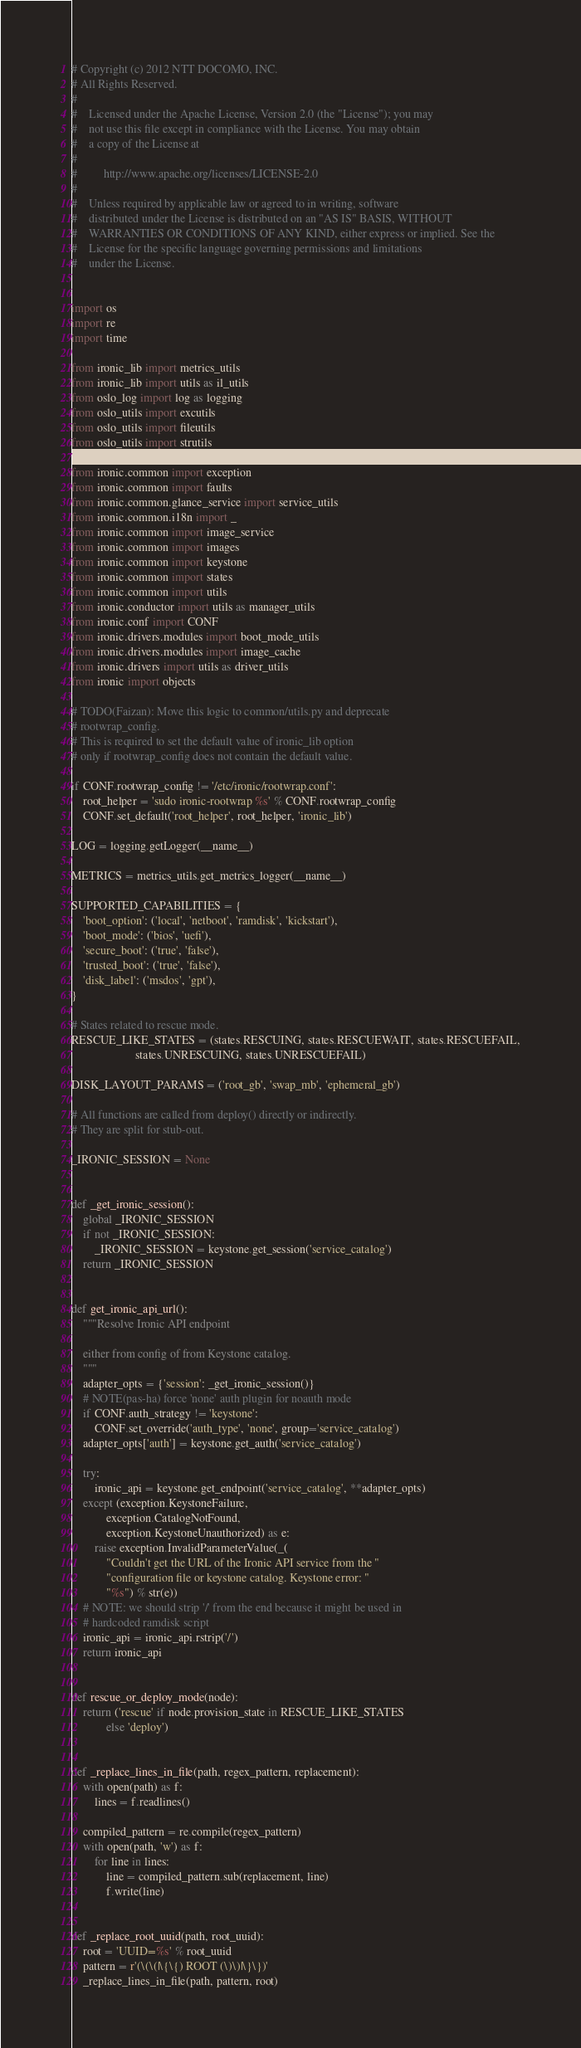Convert code to text. <code><loc_0><loc_0><loc_500><loc_500><_Python_># Copyright (c) 2012 NTT DOCOMO, INC.
# All Rights Reserved.
#
#    Licensed under the Apache License, Version 2.0 (the "License"); you may
#    not use this file except in compliance with the License. You may obtain
#    a copy of the License at
#
#         http://www.apache.org/licenses/LICENSE-2.0
#
#    Unless required by applicable law or agreed to in writing, software
#    distributed under the License is distributed on an "AS IS" BASIS, WITHOUT
#    WARRANTIES OR CONDITIONS OF ANY KIND, either express or implied. See the
#    License for the specific language governing permissions and limitations
#    under the License.


import os
import re
import time

from ironic_lib import metrics_utils
from ironic_lib import utils as il_utils
from oslo_log import log as logging
from oslo_utils import excutils
from oslo_utils import fileutils
from oslo_utils import strutils

from ironic.common import exception
from ironic.common import faults
from ironic.common.glance_service import service_utils
from ironic.common.i18n import _
from ironic.common import image_service
from ironic.common import images
from ironic.common import keystone
from ironic.common import states
from ironic.common import utils
from ironic.conductor import utils as manager_utils
from ironic.conf import CONF
from ironic.drivers.modules import boot_mode_utils
from ironic.drivers.modules import image_cache
from ironic.drivers import utils as driver_utils
from ironic import objects

# TODO(Faizan): Move this logic to common/utils.py and deprecate
# rootwrap_config.
# This is required to set the default value of ironic_lib option
# only if rootwrap_config does not contain the default value.

if CONF.rootwrap_config != '/etc/ironic/rootwrap.conf':
    root_helper = 'sudo ironic-rootwrap %s' % CONF.rootwrap_config
    CONF.set_default('root_helper', root_helper, 'ironic_lib')

LOG = logging.getLogger(__name__)

METRICS = metrics_utils.get_metrics_logger(__name__)

SUPPORTED_CAPABILITIES = {
    'boot_option': ('local', 'netboot', 'ramdisk', 'kickstart'),
    'boot_mode': ('bios', 'uefi'),
    'secure_boot': ('true', 'false'),
    'trusted_boot': ('true', 'false'),
    'disk_label': ('msdos', 'gpt'),
}

# States related to rescue mode.
RESCUE_LIKE_STATES = (states.RESCUING, states.RESCUEWAIT, states.RESCUEFAIL,
                      states.UNRESCUING, states.UNRESCUEFAIL)

DISK_LAYOUT_PARAMS = ('root_gb', 'swap_mb', 'ephemeral_gb')

# All functions are called from deploy() directly or indirectly.
# They are split for stub-out.

_IRONIC_SESSION = None


def _get_ironic_session():
    global _IRONIC_SESSION
    if not _IRONIC_SESSION:
        _IRONIC_SESSION = keystone.get_session('service_catalog')
    return _IRONIC_SESSION


def get_ironic_api_url():
    """Resolve Ironic API endpoint

    either from config of from Keystone catalog.
    """
    adapter_opts = {'session': _get_ironic_session()}
    # NOTE(pas-ha) force 'none' auth plugin for noauth mode
    if CONF.auth_strategy != 'keystone':
        CONF.set_override('auth_type', 'none', group='service_catalog')
    adapter_opts['auth'] = keystone.get_auth('service_catalog')

    try:
        ironic_api = keystone.get_endpoint('service_catalog', **adapter_opts)
    except (exception.KeystoneFailure,
            exception.CatalogNotFound,
            exception.KeystoneUnauthorized) as e:
        raise exception.InvalidParameterValue(_(
            "Couldn't get the URL of the Ironic API service from the "
            "configuration file or keystone catalog. Keystone error: "
            "%s") % str(e))
    # NOTE: we should strip '/' from the end because it might be used in
    # hardcoded ramdisk script
    ironic_api = ironic_api.rstrip('/')
    return ironic_api


def rescue_or_deploy_mode(node):
    return ('rescue' if node.provision_state in RESCUE_LIKE_STATES
            else 'deploy')


def _replace_lines_in_file(path, regex_pattern, replacement):
    with open(path) as f:
        lines = f.readlines()

    compiled_pattern = re.compile(regex_pattern)
    with open(path, 'w') as f:
        for line in lines:
            line = compiled_pattern.sub(replacement, line)
            f.write(line)


def _replace_root_uuid(path, root_uuid):
    root = 'UUID=%s' % root_uuid
    pattern = r'(\(\(|\{\{) ROOT (\)\)|\}\})'
    _replace_lines_in_file(path, pattern, root)

</code> 